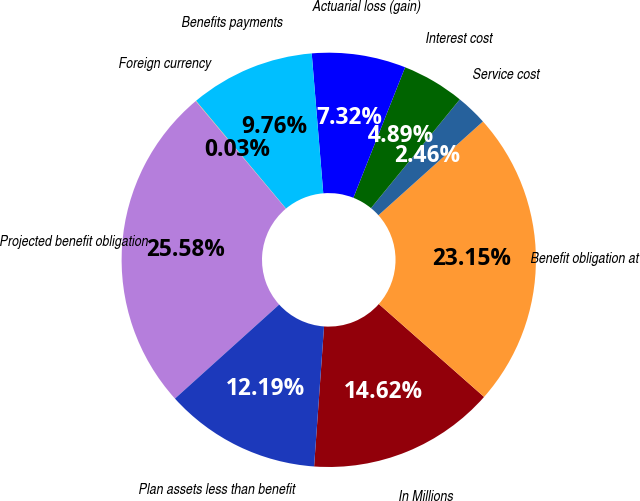<chart> <loc_0><loc_0><loc_500><loc_500><pie_chart><fcel>In Millions<fcel>Benefit obligation at<fcel>Service cost<fcel>Interest cost<fcel>Actuarial loss (gain)<fcel>Benefits payments<fcel>Foreign currency<fcel>Projected benefit obligation<fcel>Plan assets less than benefit<nl><fcel>14.62%<fcel>23.15%<fcel>2.46%<fcel>4.89%<fcel>7.32%<fcel>9.76%<fcel>0.03%<fcel>25.58%<fcel>12.19%<nl></chart> 